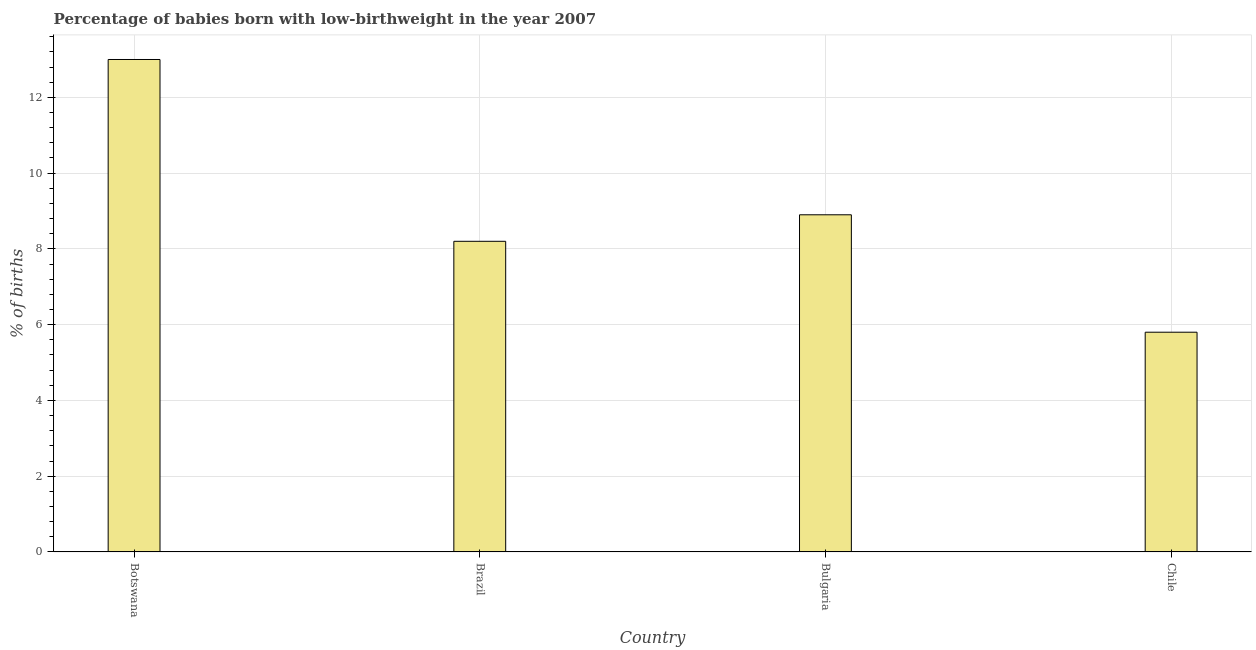Does the graph contain grids?
Ensure brevity in your answer.  Yes. What is the title of the graph?
Provide a short and direct response. Percentage of babies born with low-birthweight in the year 2007. What is the label or title of the Y-axis?
Your answer should be very brief. % of births. What is the percentage of babies who were born with low-birthweight in Bulgaria?
Your answer should be compact. 8.9. Across all countries, what is the maximum percentage of babies who were born with low-birthweight?
Your answer should be compact. 13. Across all countries, what is the minimum percentage of babies who were born with low-birthweight?
Provide a succinct answer. 5.8. In which country was the percentage of babies who were born with low-birthweight maximum?
Provide a short and direct response. Botswana. What is the sum of the percentage of babies who were born with low-birthweight?
Give a very brief answer. 35.9. What is the difference between the percentage of babies who were born with low-birthweight in Botswana and Chile?
Your answer should be very brief. 7.2. What is the average percentage of babies who were born with low-birthweight per country?
Give a very brief answer. 8.97. What is the median percentage of babies who were born with low-birthweight?
Your answer should be very brief. 8.55. What is the ratio of the percentage of babies who were born with low-birthweight in Botswana to that in Bulgaria?
Provide a short and direct response. 1.46. What is the difference between the highest and the second highest percentage of babies who were born with low-birthweight?
Your answer should be compact. 4.1. Is the sum of the percentage of babies who were born with low-birthweight in Botswana and Chile greater than the maximum percentage of babies who were born with low-birthweight across all countries?
Your answer should be very brief. Yes. What is the difference between the highest and the lowest percentage of babies who were born with low-birthweight?
Your response must be concise. 7.2. In how many countries, is the percentage of babies who were born with low-birthweight greater than the average percentage of babies who were born with low-birthweight taken over all countries?
Your answer should be very brief. 1. Are all the bars in the graph horizontal?
Give a very brief answer. No. What is the % of births of Botswana?
Offer a very short reply. 13. What is the % of births in Bulgaria?
Your response must be concise. 8.9. What is the difference between the % of births in Botswana and Chile?
Ensure brevity in your answer.  7.2. What is the difference between the % of births in Brazil and Bulgaria?
Your answer should be very brief. -0.7. What is the difference between the % of births in Brazil and Chile?
Your response must be concise. 2.4. What is the difference between the % of births in Bulgaria and Chile?
Provide a succinct answer. 3.1. What is the ratio of the % of births in Botswana to that in Brazil?
Ensure brevity in your answer.  1.58. What is the ratio of the % of births in Botswana to that in Bulgaria?
Make the answer very short. 1.46. What is the ratio of the % of births in Botswana to that in Chile?
Your answer should be compact. 2.24. What is the ratio of the % of births in Brazil to that in Bulgaria?
Ensure brevity in your answer.  0.92. What is the ratio of the % of births in Brazil to that in Chile?
Keep it short and to the point. 1.41. What is the ratio of the % of births in Bulgaria to that in Chile?
Provide a succinct answer. 1.53. 